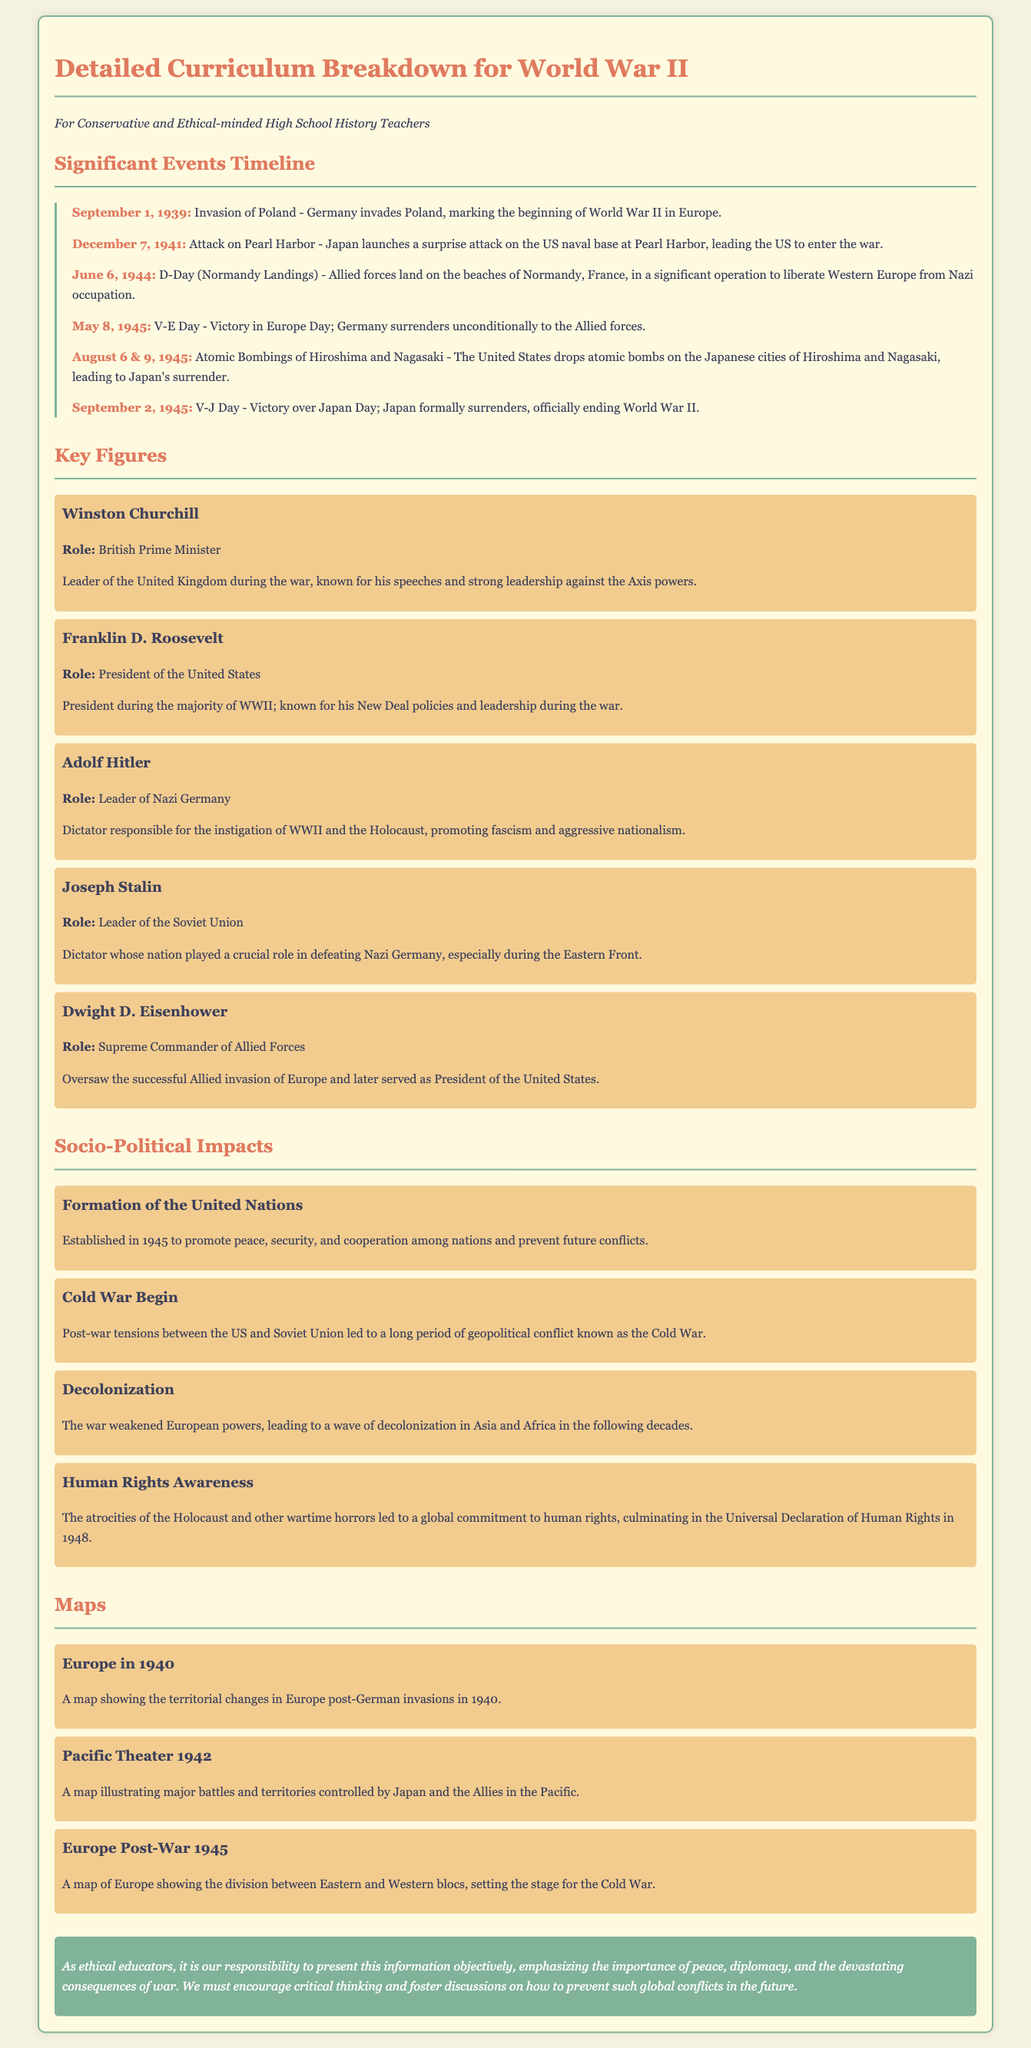what date marks the beginning of World War II in Europe? The invasion of Poland by Germany on September 1, 1939, marks the beginning of World War II in Europe.
Answer: September 1, 1939 who was the British Prime Minister during World War II? The document lists Winston Churchill as the British Prime Minister during World War II.
Answer: Winston Churchill what event is referred to as D-Day? According to the timeline, D-Day refers to the Allied forces landing on the beaches of Normandy on June 6, 1944.
Answer: Normandy Landings which city was the target of the first atomic bomb dropped by the United States? The document indicates that Hiroshima was the target of the first atomic bomb dropped by the United States.
Answer: Hiroshima what significant organization was established in 1945 to promote peace? The text states that the United Nations was established in 1945 to promote peace.
Answer: United Nations compare the roles of Stalin and Churchill in WWII. The document notes that Stalin was the leader of the Soviet Union, and Churchill was the Prime Minister of the UK, both playing crucial roles against the Axis powers.
Answer: Stalin: Soviet Union, Churchill: UK what historical impact resulted from the atrocities of the Holocaust? The document mentions that the atrocities led to a global commitment to human rights, culminating in the Universal Declaration of Human Rights in 1948.
Answer: Human Rights Awareness how many days were there between V-E Day and V-J Day? V-E Day was on May 8, 1945, and V-J Day was on September 2, 1945, representing 117 days apart.
Answer: 117 days which map illustrates major battles in the Pacific during WWII? The document specifies that the map titled "Pacific Theater 1942" illustrates major battles in the Pacific.
Answer: Pacific Theater 1942 